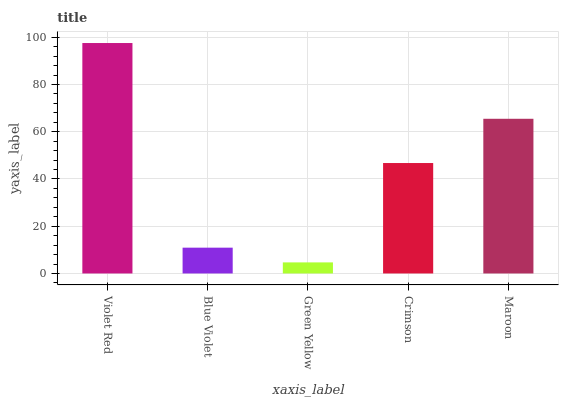Is Green Yellow the minimum?
Answer yes or no. Yes. Is Violet Red the maximum?
Answer yes or no. Yes. Is Blue Violet the minimum?
Answer yes or no. No. Is Blue Violet the maximum?
Answer yes or no. No. Is Violet Red greater than Blue Violet?
Answer yes or no. Yes. Is Blue Violet less than Violet Red?
Answer yes or no. Yes. Is Blue Violet greater than Violet Red?
Answer yes or no. No. Is Violet Red less than Blue Violet?
Answer yes or no. No. Is Crimson the high median?
Answer yes or no. Yes. Is Crimson the low median?
Answer yes or no. Yes. Is Green Yellow the high median?
Answer yes or no. No. Is Violet Red the low median?
Answer yes or no. No. 